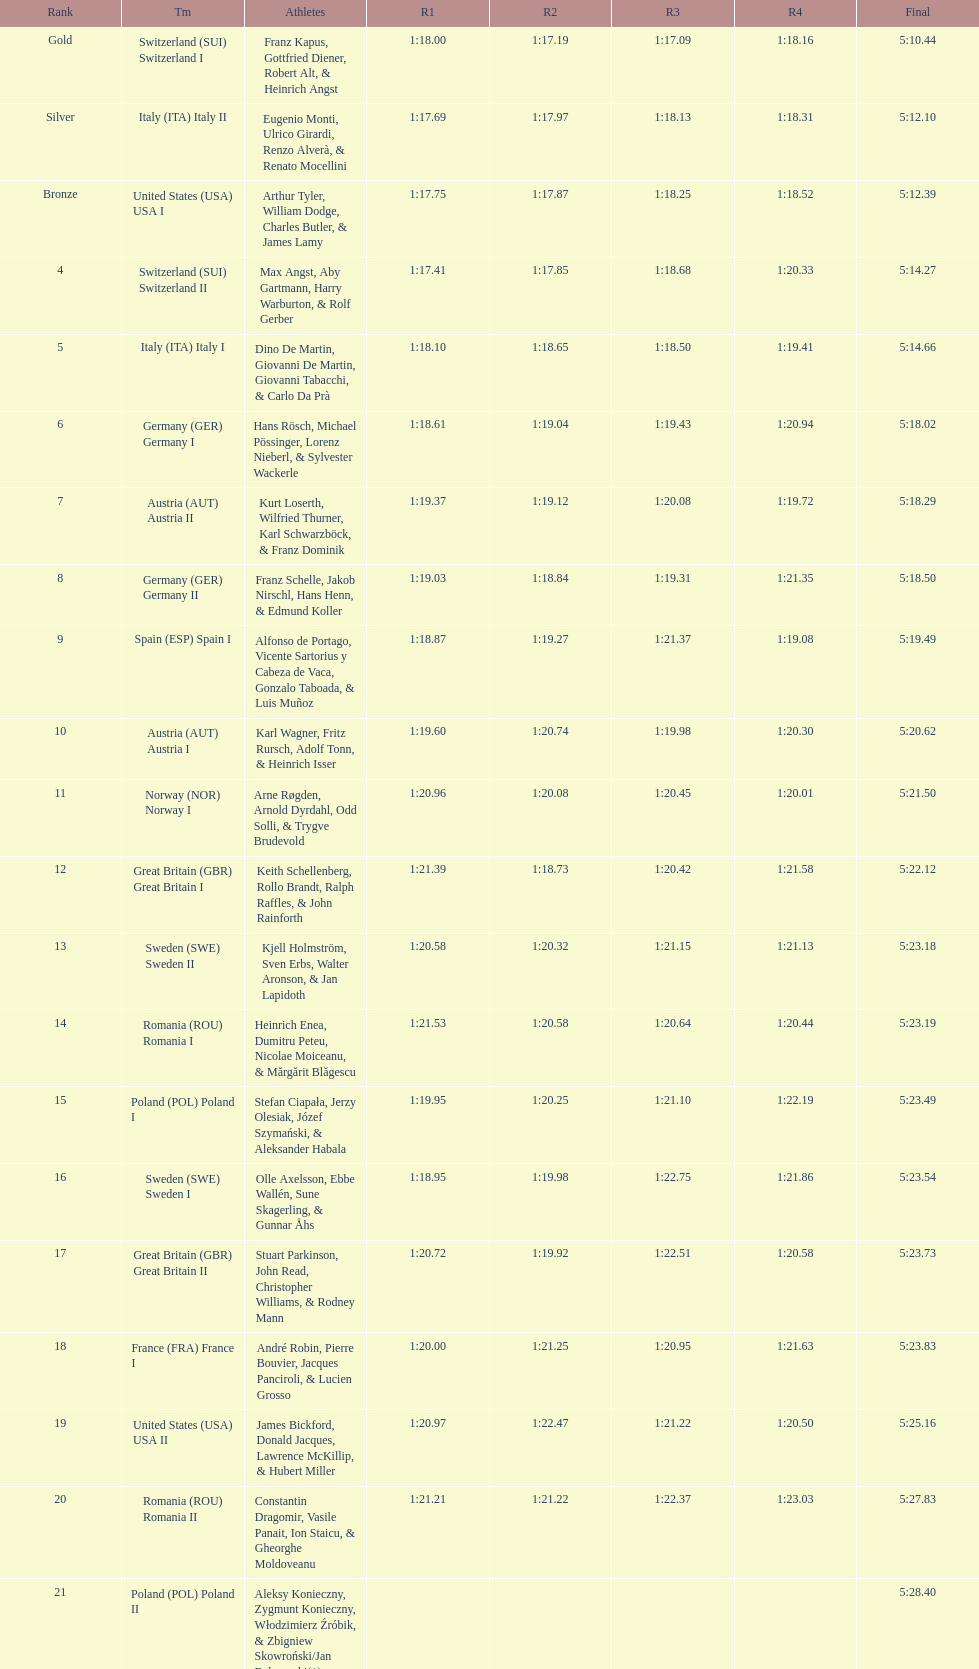What team came in second to last place? Romania. 